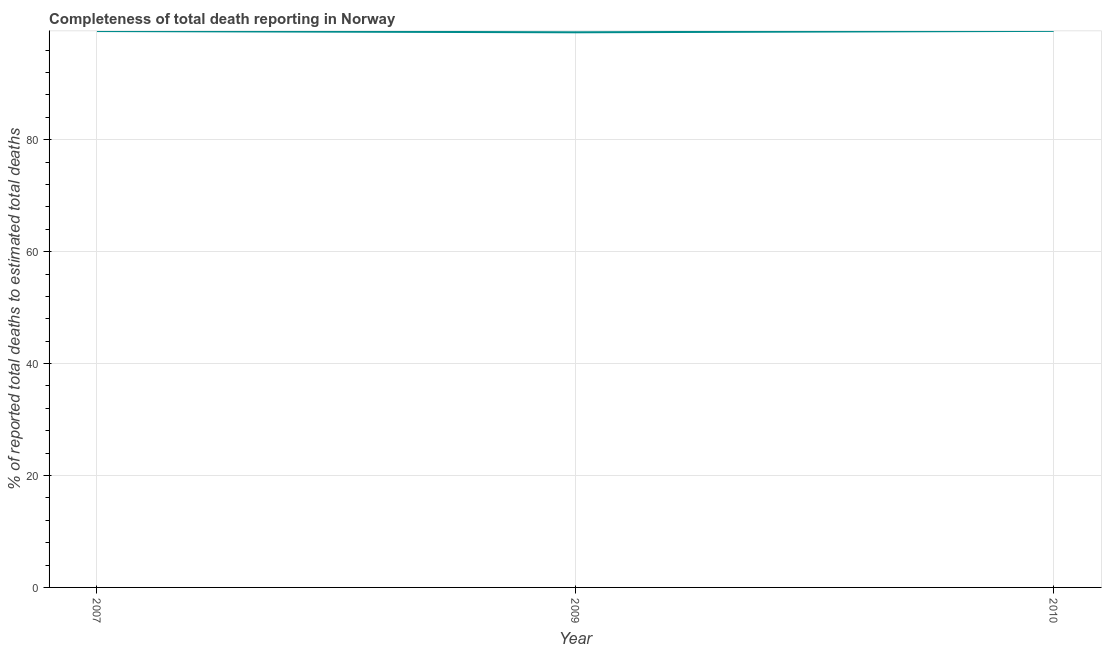What is the completeness of total death reports in 2007?
Make the answer very short. 99.41. Across all years, what is the maximum completeness of total death reports?
Your response must be concise. 99.44. Across all years, what is the minimum completeness of total death reports?
Keep it short and to the point. 99.19. In which year was the completeness of total death reports minimum?
Keep it short and to the point. 2009. What is the sum of the completeness of total death reports?
Make the answer very short. 298.04. What is the difference between the completeness of total death reports in 2009 and 2010?
Make the answer very short. -0.25. What is the average completeness of total death reports per year?
Your response must be concise. 99.35. What is the median completeness of total death reports?
Provide a succinct answer. 99.41. What is the ratio of the completeness of total death reports in 2007 to that in 2010?
Provide a short and direct response. 1. Is the completeness of total death reports in 2009 less than that in 2010?
Provide a succinct answer. Yes. What is the difference between the highest and the second highest completeness of total death reports?
Offer a terse response. 0.03. What is the difference between the highest and the lowest completeness of total death reports?
Your response must be concise. 0.25. In how many years, is the completeness of total death reports greater than the average completeness of total death reports taken over all years?
Give a very brief answer. 2. How many years are there in the graph?
Your response must be concise. 3. Are the values on the major ticks of Y-axis written in scientific E-notation?
Offer a very short reply. No. Does the graph contain any zero values?
Your answer should be very brief. No. What is the title of the graph?
Ensure brevity in your answer.  Completeness of total death reporting in Norway. What is the label or title of the X-axis?
Your answer should be compact. Year. What is the label or title of the Y-axis?
Provide a short and direct response. % of reported total deaths to estimated total deaths. What is the % of reported total deaths to estimated total deaths in 2007?
Ensure brevity in your answer.  99.41. What is the % of reported total deaths to estimated total deaths of 2009?
Your answer should be compact. 99.19. What is the % of reported total deaths to estimated total deaths of 2010?
Provide a short and direct response. 99.44. What is the difference between the % of reported total deaths to estimated total deaths in 2007 and 2009?
Your response must be concise. 0.22. What is the difference between the % of reported total deaths to estimated total deaths in 2007 and 2010?
Keep it short and to the point. -0.03. What is the difference between the % of reported total deaths to estimated total deaths in 2009 and 2010?
Provide a short and direct response. -0.25. What is the ratio of the % of reported total deaths to estimated total deaths in 2007 to that in 2009?
Provide a succinct answer. 1. What is the ratio of the % of reported total deaths to estimated total deaths in 2009 to that in 2010?
Your response must be concise. 1. 